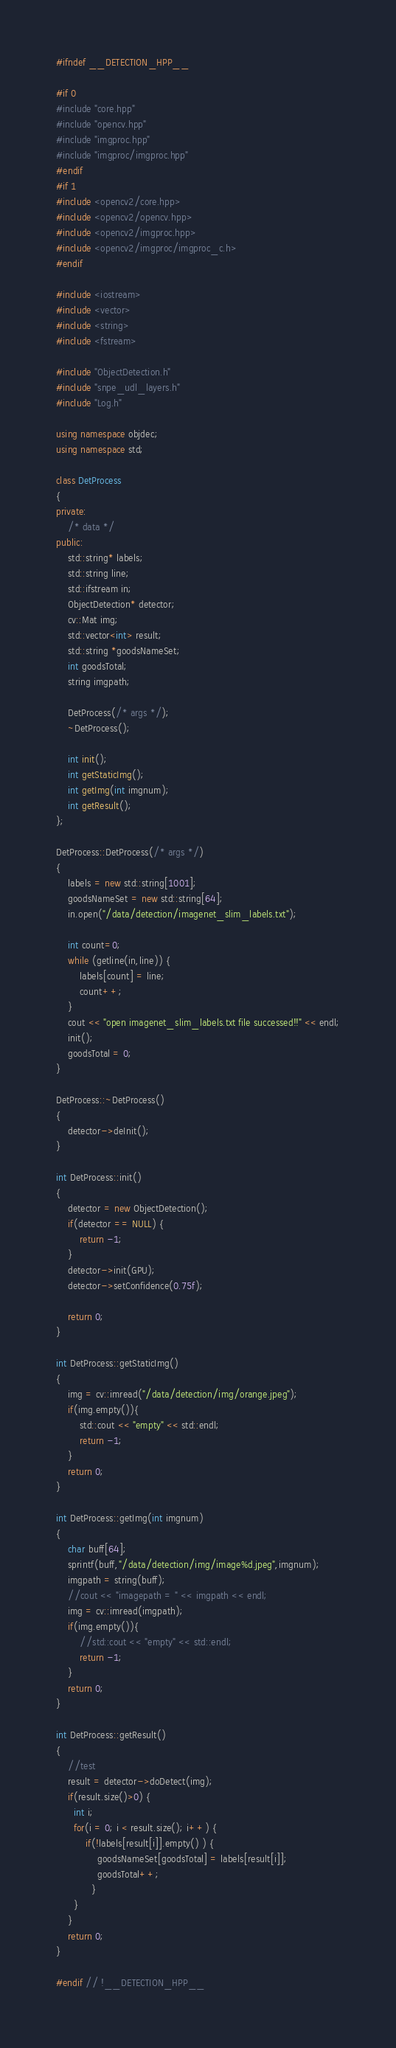<code> <loc_0><loc_0><loc_500><loc_500><_C++_>#ifndef __DETECTION_HPP__

#if 0
#include "core.hpp"
#include "opencv.hpp"
#include "imgproc.hpp"
#include "imgproc/imgproc.hpp"
#endif
#if 1
#include <opencv2/core.hpp>
#include <opencv2/opencv.hpp>
#include <opencv2/imgproc.hpp>
#include <opencv2/imgproc/imgproc_c.h>
#endif

#include <iostream>
#include <vector>
#include <string>
#include <fstream>

#include "ObjectDetection.h"
#include "snpe_udl_layers.h"
#include "Log.h"

using namespace objdec;
using namespace std;

class DetProcess
{
private:
    /* data */
public:
    std::string* labels;
    std::string line;
    std::ifstream in;
    ObjectDetection* detector;
    cv::Mat img;
    std::vector<int> result;
    std::string *goodsNameSet;
    int goodsTotal;
    string imgpath;

    DetProcess(/* args */);
    ~DetProcess();

    int init();
    int getStaticImg();
    int getImg(int imgnum);
    int getResult();
};

DetProcess::DetProcess(/* args */)
{
    labels = new std::string[1001];
    goodsNameSet = new std::string[64];
    in.open("/data/detection/imagenet_slim_labels.txt");

    int count=0;
    while (getline(in,line)) {
        labels[count] = line;
        count++; 
    }
    cout << "open imagenet_slim_labels.txt file successed!!" << endl;
    init();
    goodsTotal = 0;
}

DetProcess::~DetProcess()
{
    detector->deInit();
}

int DetProcess::init()
{
    detector = new ObjectDetection();
    if(detector == NULL) {
        return -1;
    }
    detector->init(GPU);
    detector->setConfidence(0.75f);

    return 0;
}

int DetProcess::getStaticImg()
{
    img = cv::imread("/data/detection/img/orange.jpeg");
    if(img.empty()){
        std::cout << "empty" << std::endl;
        return -1;
    }
    return 0;
}

int DetProcess::getImg(int imgnum)
{
    char buff[64];
    sprintf(buff,"/data/detection/img/image%d.jpeg",imgnum);
    imgpath = string(buff);
    //cout << "imagepath = " << imgpath << endl;
    img = cv::imread(imgpath);
    if(img.empty()){
        //std::cout << "empty" << std::endl;
        return -1;
    }
    return 0;
}

int DetProcess::getResult()
{
    //test
    result = detector->doDetect(img);
    if(result.size()>0) {
      int i;
      for(i = 0; i < result.size(); i++) {
          if(!labels[result[i]].empty() ) {
              goodsNameSet[goodsTotal] = labels[result[i]];
              goodsTotal++;
            }
      }
    }
    return 0;
}

#endif // !__DETECTION_HPP__

</code> 